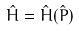Convert formula to latex. <formula><loc_0><loc_0><loc_500><loc_500>\hat { H } = \hat { H } ( \hat { P } )</formula> 